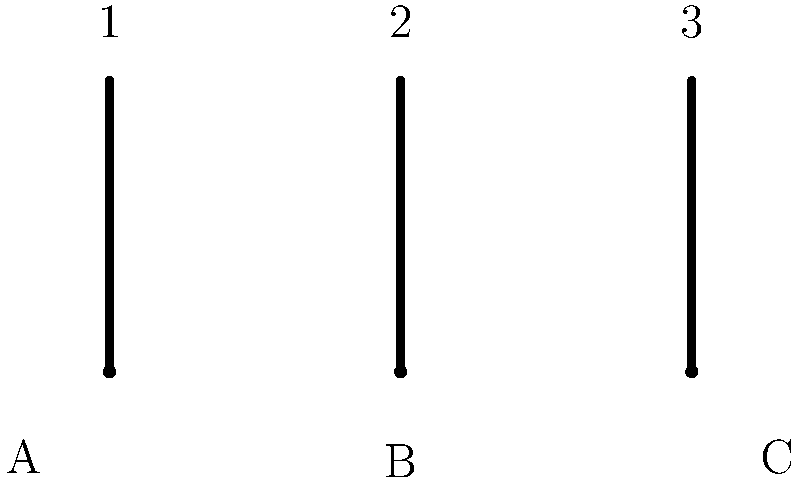Consider a tattoo machine with three needles arranged as shown in the diagram. The needles can be configured to either touch the skin (down position) or not touch the skin (up position). How many topologically distinct surfaces can be created by different combinations of needle positions, and what is the genus of the surface with the highest genus among these configurations? Let's approach this step-by-step:

1. First, we need to count the number of possible configurations:
   - Each needle can be either up or down
   - With 3 needles, we have $2^3 = 8$ possible configurations

2. Now, let's consider the topological surfaces created:
   - When all needles are up: No surface is created (0 genus)
   - When one needle is down: A single point is created (0 genus)
   - When two needles are down: A line segment is created (0 genus)
   - When all three needles are down: A triangle is created (0 genus)

3. The key observation is that all these configurations create surfaces with genus 0. 
   This is because they are all simply connected and can be continuously deformed into a sphere.

4. Therefore, we have:
   - 1 configuration with no surface
   - 3 configurations with a single point
   - 3 configurations with a line segment
   - 1 configuration with a triangle

5. In total, we have 7 topologically distinct surfaces (counting the "no surface" as a distinct case), all with genus 0.

6. The surface with the highest genus among these configurations is still 0.
Answer: 7 distinct surfaces; highest genus is 0 